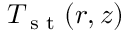Convert formula to latex. <formula><loc_0><loc_0><loc_500><loc_500>T _ { s t } ( r , z )</formula> 